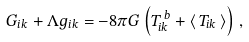Convert formula to latex. <formula><loc_0><loc_0><loc_500><loc_500>G _ { i k } + \Lambda g _ { i k } = - 8 \pi G \left ( T _ { i k } ^ { \, b } + \langle \, T _ { i k } \, \rangle \right ) \, ,</formula> 